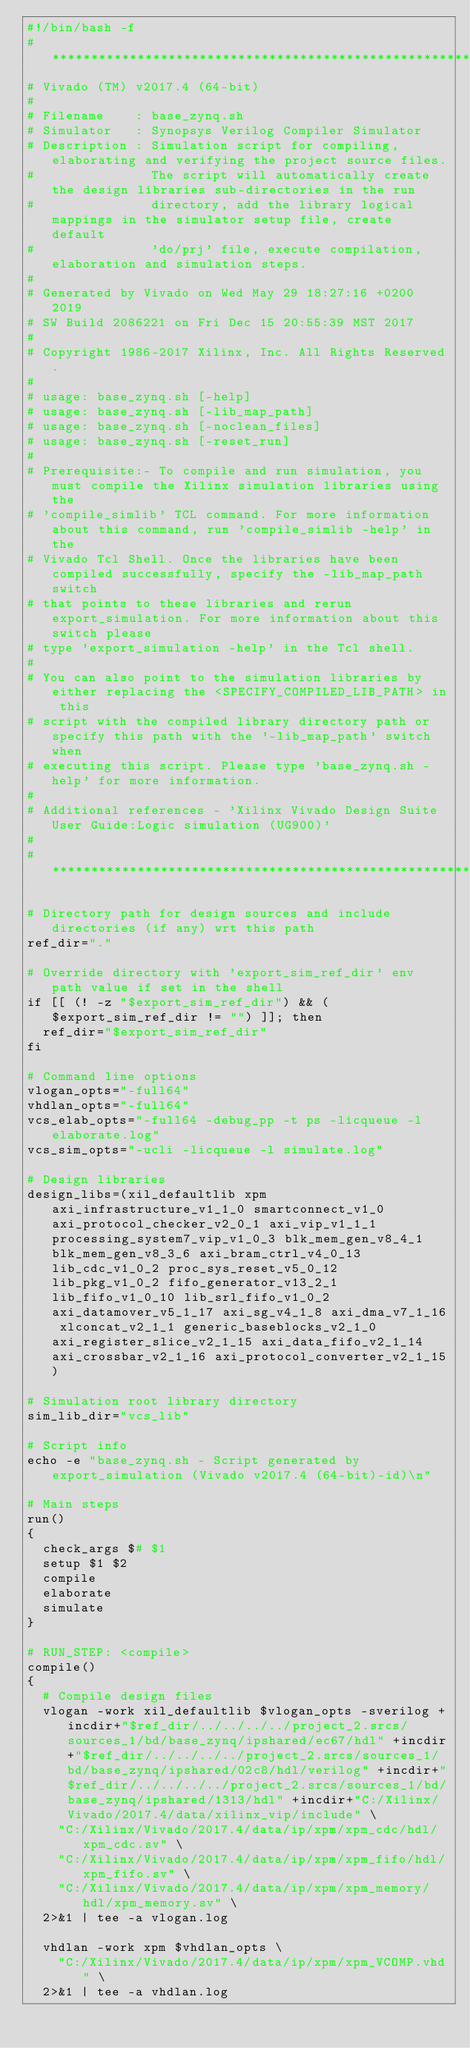Convert code to text. <code><loc_0><loc_0><loc_500><loc_500><_Bash_>#!/bin/bash -f
#*********************************************************************************************************
# Vivado (TM) v2017.4 (64-bit)
#
# Filename    : base_zynq.sh
# Simulator   : Synopsys Verilog Compiler Simulator
# Description : Simulation script for compiling, elaborating and verifying the project source files.
#               The script will automatically create the design libraries sub-directories in the run
#               directory, add the library logical mappings in the simulator setup file, create default
#               'do/prj' file, execute compilation, elaboration and simulation steps.
#
# Generated by Vivado on Wed May 29 18:27:16 +0200 2019
# SW Build 2086221 on Fri Dec 15 20:55:39 MST 2017
#
# Copyright 1986-2017 Xilinx, Inc. All Rights Reserved. 
#
# usage: base_zynq.sh [-help]
# usage: base_zynq.sh [-lib_map_path]
# usage: base_zynq.sh [-noclean_files]
# usage: base_zynq.sh [-reset_run]
#
# Prerequisite:- To compile and run simulation, you must compile the Xilinx simulation libraries using the
# 'compile_simlib' TCL command. For more information about this command, run 'compile_simlib -help' in the
# Vivado Tcl Shell. Once the libraries have been compiled successfully, specify the -lib_map_path switch
# that points to these libraries and rerun export_simulation. For more information about this switch please
# type 'export_simulation -help' in the Tcl shell.
#
# You can also point to the simulation libraries by either replacing the <SPECIFY_COMPILED_LIB_PATH> in this
# script with the compiled library directory path or specify this path with the '-lib_map_path' switch when
# executing this script. Please type 'base_zynq.sh -help' for more information.
#
# Additional references - 'Xilinx Vivado Design Suite User Guide:Logic simulation (UG900)'
#
#*********************************************************************************************************

# Directory path for design sources and include directories (if any) wrt this path
ref_dir="."

# Override directory with 'export_sim_ref_dir' env path value if set in the shell
if [[ (! -z "$export_sim_ref_dir") && ($export_sim_ref_dir != "") ]]; then
  ref_dir="$export_sim_ref_dir"
fi

# Command line options
vlogan_opts="-full64"
vhdlan_opts="-full64"
vcs_elab_opts="-full64 -debug_pp -t ps -licqueue -l elaborate.log"
vcs_sim_opts="-ucli -licqueue -l simulate.log"

# Design libraries
design_libs=(xil_defaultlib xpm axi_infrastructure_v1_1_0 smartconnect_v1_0 axi_protocol_checker_v2_0_1 axi_vip_v1_1_1 processing_system7_vip_v1_0_3 blk_mem_gen_v8_4_1 blk_mem_gen_v8_3_6 axi_bram_ctrl_v4_0_13 lib_cdc_v1_0_2 proc_sys_reset_v5_0_12 lib_pkg_v1_0_2 fifo_generator_v13_2_1 lib_fifo_v1_0_10 lib_srl_fifo_v1_0_2 axi_datamover_v5_1_17 axi_sg_v4_1_8 axi_dma_v7_1_16 xlconcat_v2_1_1 generic_baseblocks_v2_1_0 axi_register_slice_v2_1_15 axi_data_fifo_v2_1_14 axi_crossbar_v2_1_16 axi_protocol_converter_v2_1_15)

# Simulation root library directory
sim_lib_dir="vcs_lib"

# Script info
echo -e "base_zynq.sh - Script generated by export_simulation (Vivado v2017.4 (64-bit)-id)\n"

# Main steps
run()
{
  check_args $# $1
  setup $1 $2
  compile
  elaborate
  simulate
}

# RUN_STEP: <compile>
compile()
{
  # Compile design files
  vlogan -work xil_defaultlib $vlogan_opts -sverilog +incdir+"$ref_dir/../../../../project_2.srcs/sources_1/bd/base_zynq/ipshared/ec67/hdl" +incdir+"$ref_dir/../../../../project_2.srcs/sources_1/bd/base_zynq/ipshared/02c8/hdl/verilog" +incdir+"$ref_dir/../../../../project_2.srcs/sources_1/bd/base_zynq/ipshared/1313/hdl" +incdir+"C:/Xilinx/Vivado/2017.4/data/xilinx_vip/include" \
    "C:/Xilinx/Vivado/2017.4/data/ip/xpm/xpm_cdc/hdl/xpm_cdc.sv" \
    "C:/Xilinx/Vivado/2017.4/data/ip/xpm/xpm_fifo/hdl/xpm_fifo.sv" \
    "C:/Xilinx/Vivado/2017.4/data/ip/xpm/xpm_memory/hdl/xpm_memory.sv" \
  2>&1 | tee -a vlogan.log

  vhdlan -work xpm $vhdlan_opts \
    "C:/Xilinx/Vivado/2017.4/data/ip/xpm/xpm_VCOMP.vhd" \
  2>&1 | tee -a vhdlan.log
</code> 